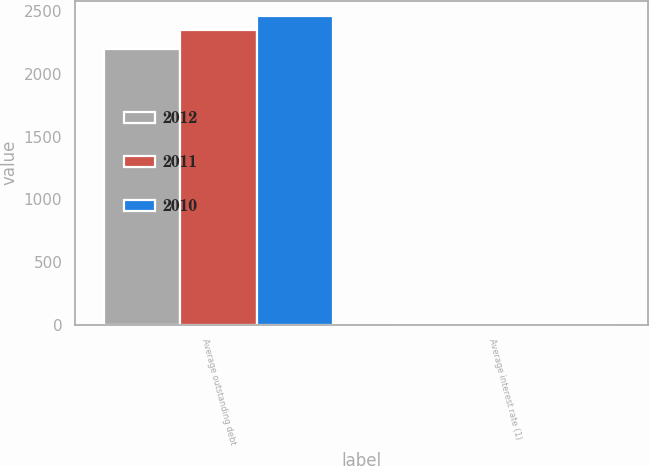Convert chart to OTSL. <chart><loc_0><loc_0><loc_500><loc_500><stacked_bar_chart><ecel><fcel>Average outstanding debt<fcel>Average interest rate (1)<nl><fcel>2012<fcel>2195.5<fcel>3.5<nl><fcel>2011<fcel>2351.3<fcel>3.6<nl><fcel>2010<fcel>2461<fcel>4.8<nl></chart> 